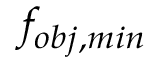Convert formula to latex. <formula><loc_0><loc_0><loc_500><loc_500>f _ { o b j , \min }</formula> 